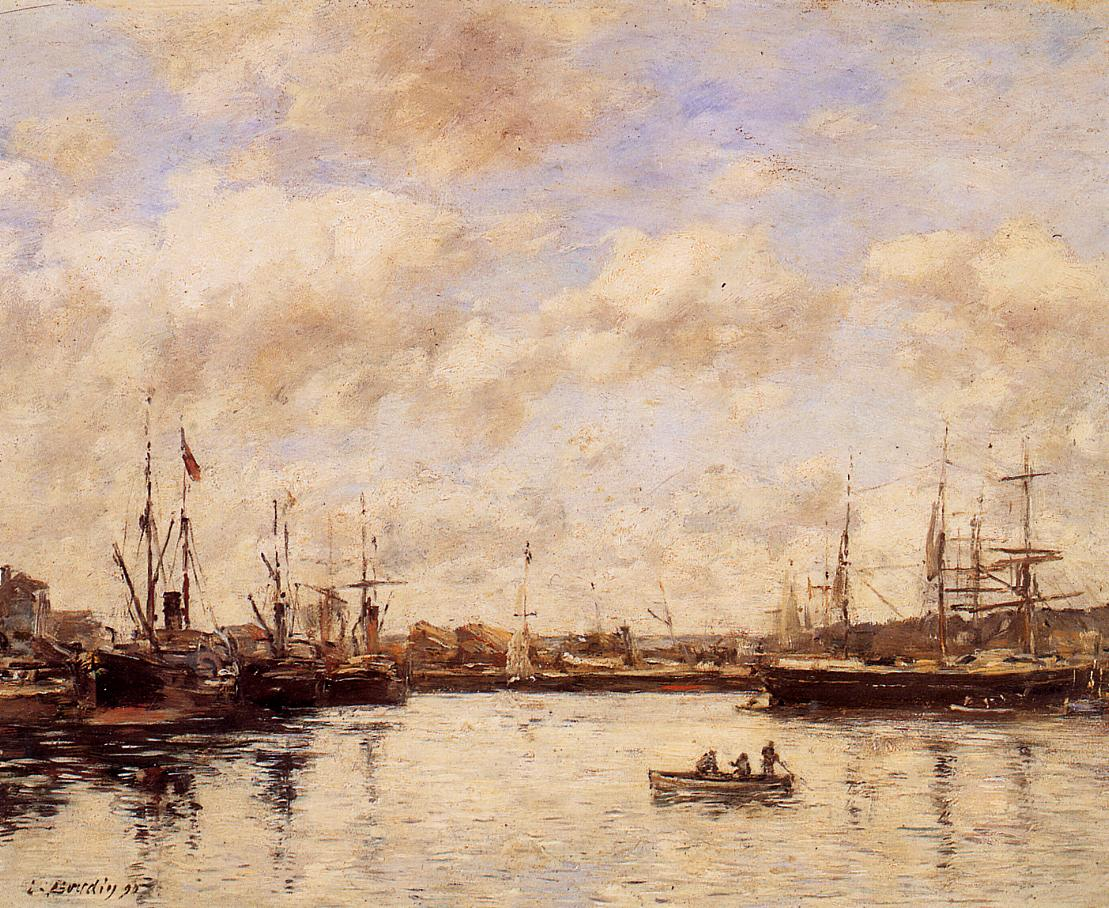If you were one of the people in the rowboat, how would you describe your experience? Being in the rowboat amidst this tranquil harbor would be an incredibly peaceful experience. The gentle rocking of the boat on the calm water, the soft sound of ripples as the oars dip into the water, and the backdrop of the serene sky and scattered ships combine to create a moment of pure tranquility. The muted colors of the scene would add to the feeling of being enveloped in a quiet, reflective atmosphere, away from the bustle of life. Imagine if every brushstroke represented a whisper. What story could these whispers be telling? If every brushstroke in this painting represented a whisper, they might be telling the story of the harbor's quiet resilience and timeless beauty. Soft whispers of the ships' journeys, the daily routines of sailors, and the gentle lapping of water against the hulls could be heard. Some whispers might speak of far-off lands and adventures, while others tell tales of patience and quiet waiting during calm days. The whispers would blend into a harmonious narrative of life's ebb and flow, captured in a serene moment of stillness. 